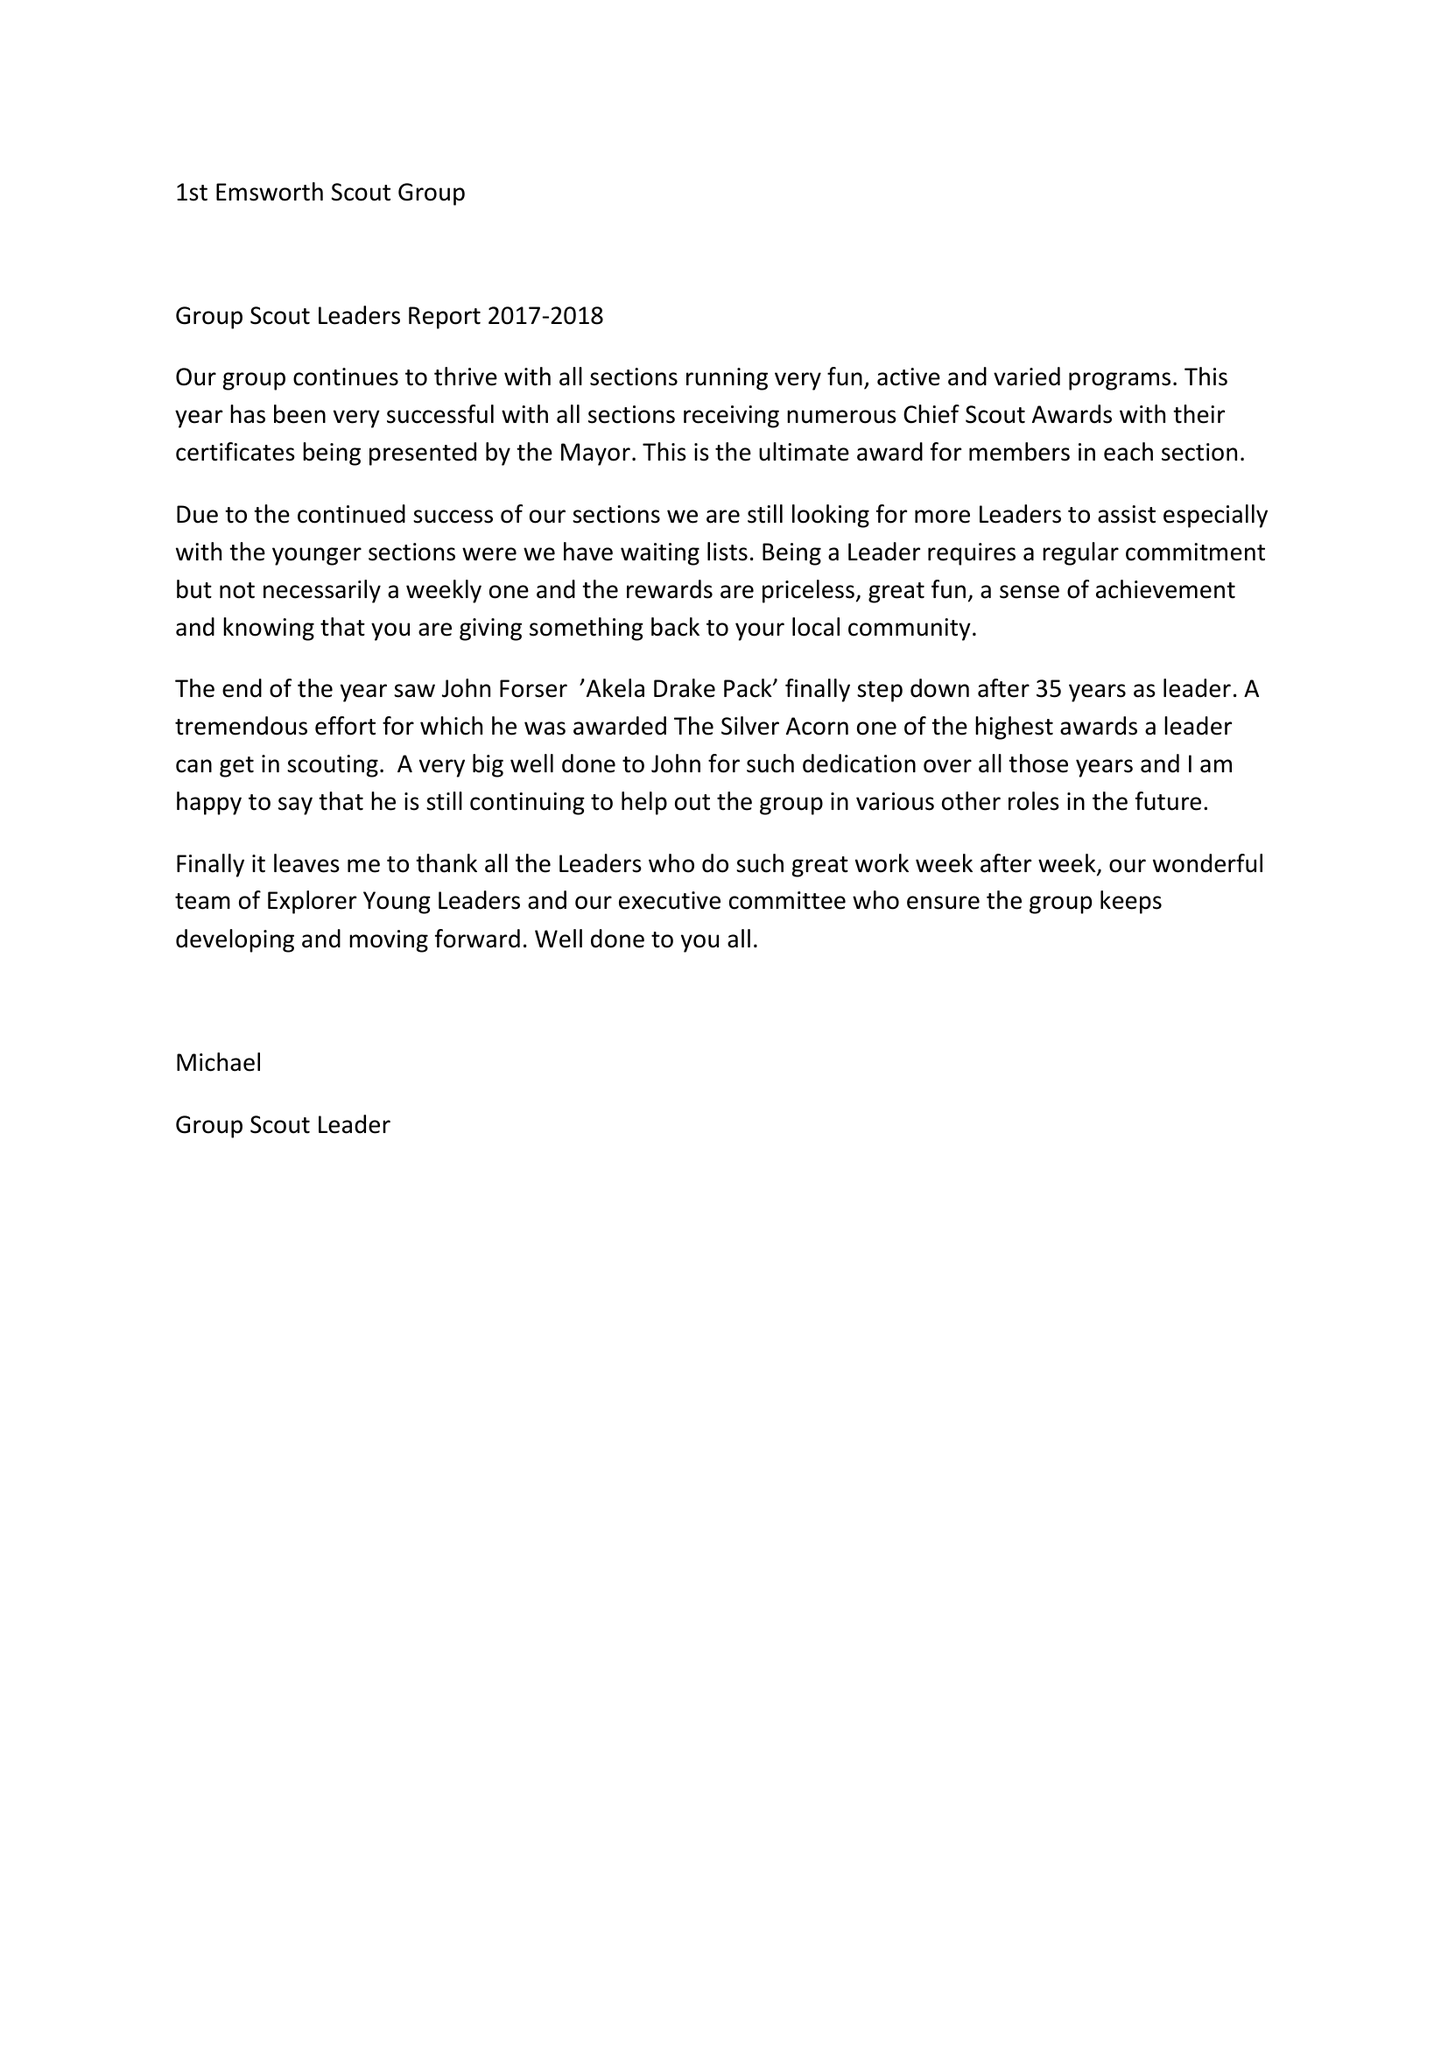What is the value for the address__post_town?
Answer the question using a single word or phrase. HAYLING ISLAND 